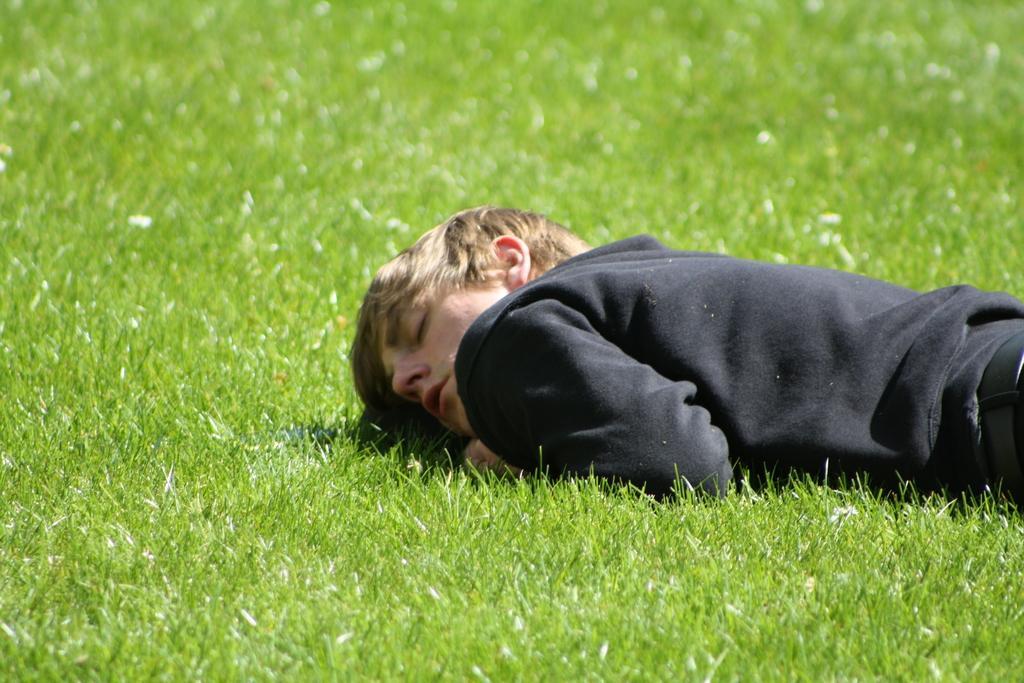Describe this image in one or two sentences. In this image there is a person lay on the surface of the grass. 